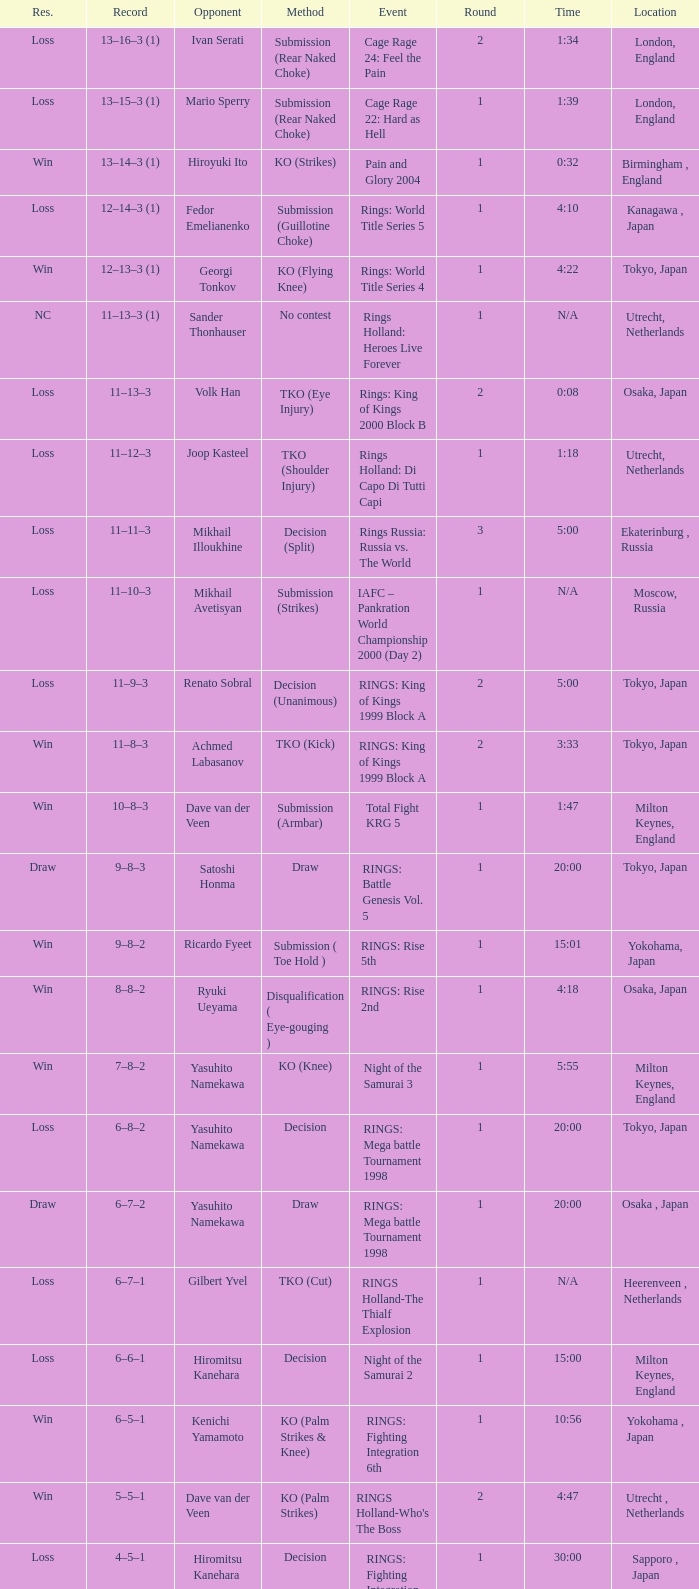Which event had an opponent of Yasuhito Namekawa with a decision method? RINGS: Mega battle Tournament 1998. 